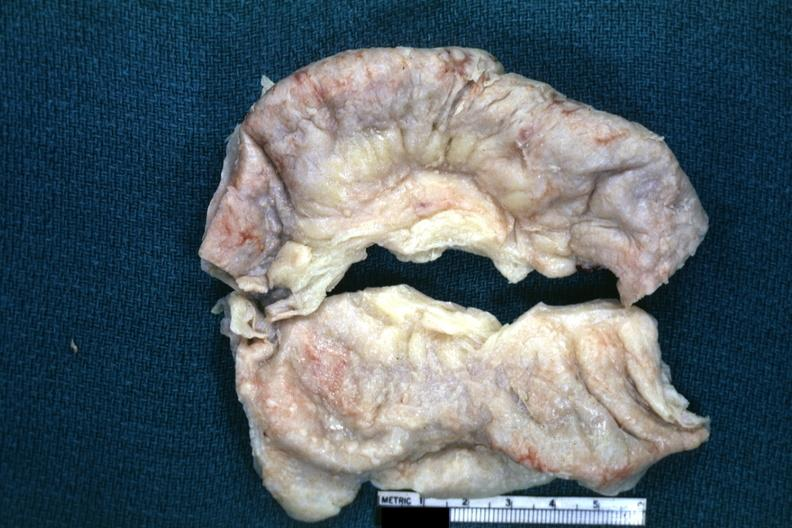does acute peritonitis show fixed tissue typical appearance of tuberculous peritonitis except for color being off a bit?
Answer the question using a single word or phrase. No 